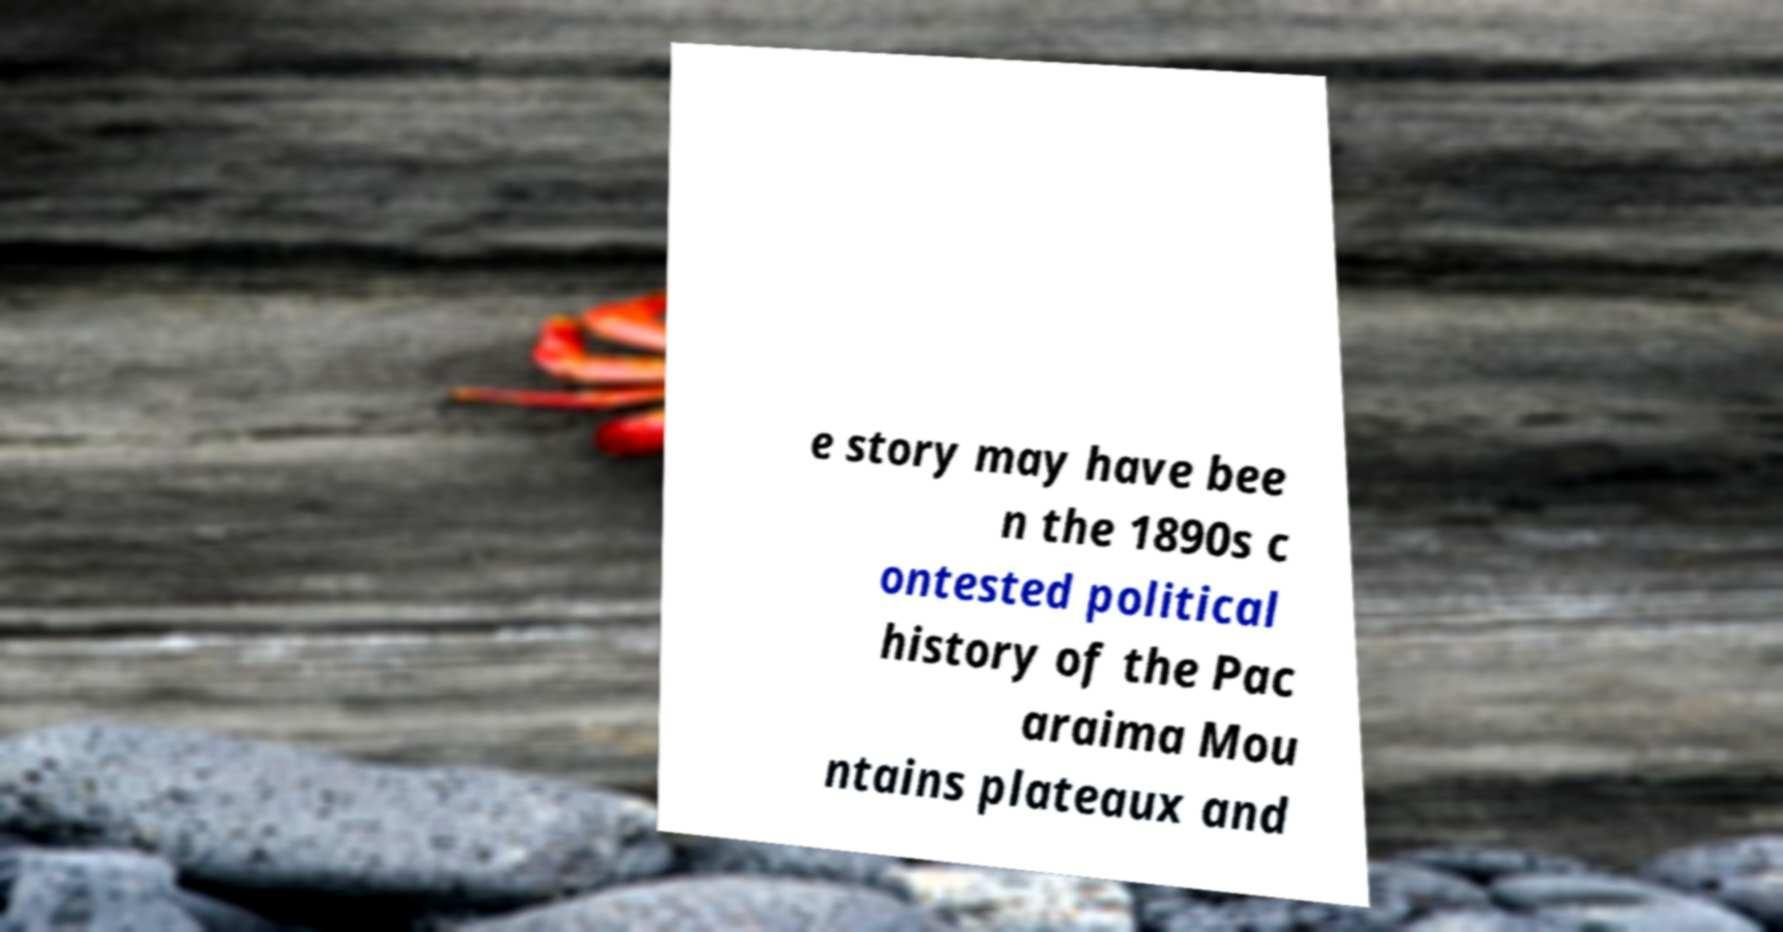Can you read and provide the text displayed in the image?This photo seems to have some interesting text. Can you extract and type it out for me? e story may have bee n the 1890s c ontested political history of the Pac araima Mou ntains plateaux and 